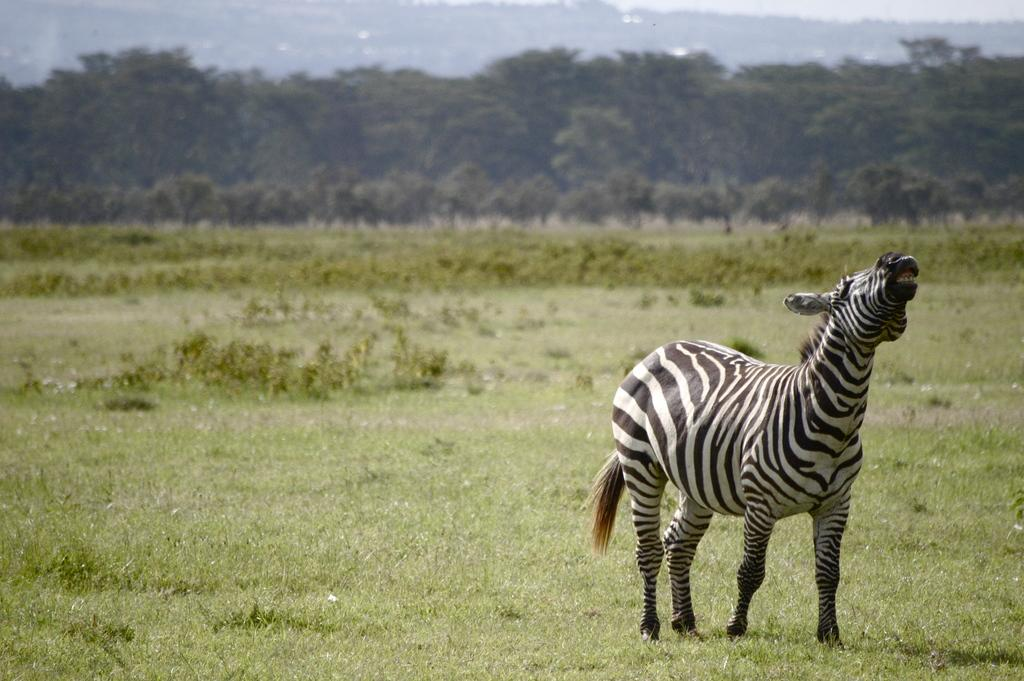What type of animal is on the surface in the image? There is a bird on the surface in the image. What can be seen in the background of the image? There is water visible in the background of the image. What type of paper is the bird using to fly in the image? There is no paper present in the image, and the bird is not using any paper to fly. 